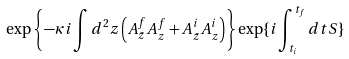Convert formula to latex. <formula><loc_0><loc_0><loc_500><loc_500>\exp \left \{ - \kappa i \int d ^ { 2 } z \left ( A ^ { f } _ { \bar { z } } A ^ { f } _ { z } + A ^ { i } _ { \bar { z } } A ^ { i } _ { z } \right ) \right \} \exp \{ i \int ^ { t _ { f } } _ { t _ { i } } d t S \}</formula> 